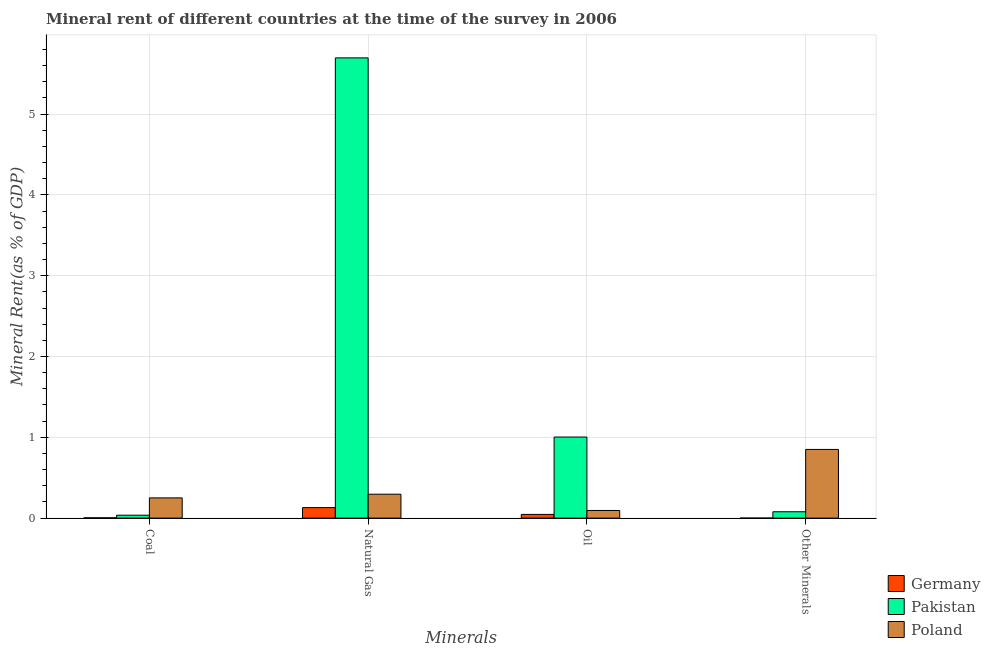How many different coloured bars are there?
Make the answer very short. 3. Are the number of bars per tick equal to the number of legend labels?
Provide a succinct answer. Yes. What is the label of the 4th group of bars from the left?
Your response must be concise. Other Minerals. What is the natural gas rent in Germany?
Your answer should be very brief. 0.13. Across all countries, what is the maximum  rent of other minerals?
Provide a short and direct response. 0.85. Across all countries, what is the minimum natural gas rent?
Give a very brief answer. 0.13. What is the total natural gas rent in the graph?
Your response must be concise. 6.12. What is the difference between the coal rent in Germany and that in Poland?
Your response must be concise. -0.25. What is the difference between the  rent of other minerals in Pakistan and the oil rent in Germany?
Your response must be concise. 0.03. What is the average coal rent per country?
Offer a terse response. 0.1. What is the difference between the  rent of other minerals and coal rent in Pakistan?
Give a very brief answer. 0.04. What is the ratio of the coal rent in Pakistan to that in Germany?
Give a very brief answer. 9.42. Is the oil rent in Germany less than that in Pakistan?
Make the answer very short. Yes. Is the difference between the oil rent in Poland and Pakistan greater than the difference between the coal rent in Poland and Pakistan?
Provide a short and direct response. No. What is the difference between the highest and the second highest coal rent?
Offer a terse response. 0.21. What is the difference between the highest and the lowest  rent of other minerals?
Your response must be concise. 0.85. How many bars are there?
Offer a terse response. 12. How many countries are there in the graph?
Your response must be concise. 3. Does the graph contain any zero values?
Your response must be concise. No. Where does the legend appear in the graph?
Give a very brief answer. Bottom right. How are the legend labels stacked?
Your response must be concise. Vertical. What is the title of the graph?
Give a very brief answer. Mineral rent of different countries at the time of the survey in 2006. Does "Guinea-Bissau" appear as one of the legend labels in the graph?
Offer a terse response. No. What is the label or title of the X-axis?
Provide a succinct answer. Minerals. What is the label or title of the Y-axis?
Offer a very short reply. Mineral Rent(as % of GDP). What is the Mineral Rent(as % of GDP) in Germany in Coal?
Make the answer very short. 0. What is the Mineral Rent(as % of GDP) of Pakistan in Coal?
Offer a very short reply. 0.04. What is the Mineral Rent(as % of GDP) in Poland in Coal?
Make the answer very short. 0.25. What is the Mineral Rent(as % of GDP) of Germany in Natural Gas?
Ensure brevity in your answer.  0.13. What is the Mineral Rent(as % of GDP) in Pakistan in Natural Gas?
Give a very brief answer. 5.7. What is the Mineral Rent(as % of GDP) of Poland in Natural Gas?
Your answer should be very brief. 0.3. What is the Mineral Rent(as % of GDP) of Germany in Oil?
Your answer should be compact. 0.05. What is the Mineral Rent(as % of GDP) in Pakistan in Oil?
Give a very brief answer. 1. What is the Mineral Rent(as % of GDP) in Poland in Oil?
Your answer should be very brief. 0.09. What is the Mineral Rent(as % of GDP) in Germany in Other Minerals?
Give a very brief answer. 0. What is the Mineral Rent(as % of GDP) of Pakistan in Other Minerals?
Your answer should be compact. 0.08. What is the Mineral Rent(as % of GDP) of Poland in Other Minerals?
Offer a very short reply. 0.85. Across all Minerals, what is the maximum Mineral Rent(as % of GDP) in Germany?
Offer a very short reply. 0.13. Across all Minerals, what is the maximum Mineral Rent(as % of GDP) in Pakistan?
Your answer should be very brief. 5.7. Across all Minerals, what is the maximum Mineral Rent(as % of GDP) of Poland?
Your response must be concise. 0.85. Across all Minerals, what is the minimum Mineral Rent(as % of GDP) in Germany?
Give a very brief answer. 0. Across all Minerals, what is the minimum Mineral Rent(as % of GDP) in Pakistan?
Keep it short and to the point. 0.04. Across all Minerals, what is the minimum Mineral Rent(as % of GDP) in Poland?
Your response must be concise. 0.09. What is the total Mineral Rent(as % of GDP) in Germany in the graph?
Provide a short and direct response. 0.18. What is the total Mineral Rent(as % of GDP) in Pakistan in the graph?
Offer a very short reply. 6.81. What is the total Mineral Rent(as % of GDP) in Poland in the graph?
Offer a very short reply. 1.49. What is the difference between the Mineral Rent(as % of GDP) of Germany in Coal and that in Natural Gas?
Give a very brief answer. -0.13. What is the difference between the Mineral Rent(as % of GDP) in Pakistan in Coal and that in Natural Gas?
Offer a terse response. -5.66. What is the difference between the Mineral Rent(as % of GDP) of Poland in Coal and that in Natural Gas?
Your answer should be very brief. -0.05. What is the difference between the Mineral Rent(as % of GDP) in Germany in Coal and that in Oil?
Provide a short and direct response. -0.04. What is the difference between the Mineral Rent(as % of GDP) of Pakistan in Coal and that in Oil?
Provide a short and direct response. -0.97. What is the difference between the Mineral Rent(as % of GDP) of Poland in Coal and that in Oil?
Your answer should be very brief. 0.16. What is the difference between the Mineral Rent(as % of GDP) of Germany in Coal and that in Other Minerals?
Provide a short and direct response. 0. What is the difference between the Mineral Rent(as % of GDP) of Pakistan in Coal and that in Other Minerals?
Keep it short and to the point. -0.04. What is the difference between the Mineral Rent(as % of GDP) of Poland in Coal and that in Other Minerals?
Provide a short and direct response. -0.6. What is the difference between the Mineral Rent(as % of GDP) in Germany in Natural Gas and that in Oil?
Offer a terse response. 0.08. What is the difference between the Mineral Rent(as % of GDP) of Pakistan in Natural Gas and that in Oil?
Give a very brief answer. 4.69. What is the difference between the Mineral Rent(as % of GDP) of Poland in Natural Gas and that in Oil?
Give a very brief answer. 0.2. What is the difference between the Mineral Rent(as % of GDP) in Germany in Natural Gas and that in Other Minerals?
Provide a succinct answer. 0.13. What is the difference between the Mineral Rent(as % of GDP) of Pakistan in Natural Gas and that in Other Minerals?
Your answer should be very brief. 5.62. What is the difference between the Mineral Rent(as % of GDP) of Poland in Natural Gas and that in Other Minerals?
Your response must be concise. -0.55. What is the difference between the Mineral Rent(as % of GDP) of Germany in Oil and that in Other Minerals?
Your answer should be compact. 0.05. What is the difference between the Mineral Rent(as % of GDP) of Pakistan in Oil and that in Other Minerals?
Your answer should be very brief. 0.92. What is the difference between the Mineral Rent(as % of GDP) in Poland in Oil and that in Other Minerals?
Your response must be concise. -0.76. What is the difference between the Mineral Rent(as % of GDP) of Germany in Coal and the Mineral Rent(as % of GDP) of Pakistan in Natural Gas?
Ensure brevity in your answer.  -5.69. What is the difference between the Mineral Rent(as % of GDP) in Germany in Coal and the Mineral Rent(as % of GDP) in Poland in Natural Gas?
Your answer should be very brief. -0.29. What is the difference between the Mineral Rent(as % of GDP) in Pakistan in Coal and the Mineral Rent(as % of GDP) in Poland in Natural Gas?
Provide a short and direct response. -0.26. What is the difference between the Mineral Rent(as % of GDP) in Germany in Coal and the Mineral Rent(as % of GDP) in Pakistan in Oil?
Offer a terse response. -1. What is the difference between the Mineral Rent(as % of GDP) in Germany in Coal and the Mineral Rent(as % of GDP) in Poland in Oil?
Your answer should be very brief. -0.09. What is the difference between the Mineral Rent(as % of GDP) in Pakistan in Coal and the Mineral Rent(as % of GDP) in Poland in Oil?
Offer a terse response. -0.06. What is the difference between the Mineral Rent(as % of GDP) of Germany in Coal and the Mineral Rent(as % of GDP) of Pakistan in Other Minerals?
Make the answer very short. -0.07. What is the difference between the Mineral Rent(as % of GDP) in Germany in Coal and the Mineral Rent(as % of GDP) in Poland in Other Minerals?
Offer a very short reply. -0.85. What is the difference between the Mineral Rent(as % of GDP) of Pakistan in Coal and the Mineral Rent(as % of GDP) of Poland in Other Minerals?
Make the answer very short. -0.81. What is the difference between the Mineral Rent(as % of GDP) in Germany in Natural Gas and the Mineral Rent(as % of GDP) in Pakistan in Oil?
Your answer should be very brief. -0.87. What is the difference between the Mineral Rent(as % of GDP) of Germany in Natural Gas and the Mineral Rent(as % of GDP) of Poland in Oil?
Keep it short and to the point. 0.04. What is the difference between the Mineral Rent(as % of GDP) in Pakistan in Natural Gas and the Mineral Rent(as % of GDP) in Poland in Oil?
Your answer should be compact. 5.6. What is the difference between the Mineral Rent(as % of GDP) in Germany in Natural Gas and the Mineral Rent(as % of GDP) in Pakistan in Other Minerals?
Keep it short and to the point. 0.05. What is the difference between the Mineral Rent(as % of GDP) in Germany in Natural Gas and the Mineral Rent(as % of GDP) in Poland in Other Minerals?
Provide a short and direct response. -0.72. What is the difference between the Mineral Rent(as % of GDP) of Pakistan in Natural Gas and the Mineral Rent(as % of GDP) of Poland in Other Minerals?
Keep it short and to the point. 4.85. What is the difference between the Mineral Rent(as % of GDP) in Germany in Oil and the Mineral Rent(as % of GDP) in Pakistan in Other Minerals?
Provide a short and direct response. -0.03. What is the difference between the Mineral Rent(as % of GDP) in Germany in Oil and the Mineral Rent(as % of GDP) in Poland in Other Minerals?
Your answer should be compact. -0.8. What is the difference between the Mineral Rent(as % of GDP) of Pakistan in Oil and the Mineral Rent(as % of GDP) of Poland in Other Minerals?
Provide a succinct answer. 0.15. What is the average Mineral Rent(as % of GDP) of Germany per Minerals?
Keep it short and to the point. 0.05. What is the average Mineral Rent(as % of GDP) of Pakistan per Minerals?
Your answer should be compact. 1.7. What is the average Mineral Rent(as % of GDP) of Poland per Minerals?
Ensure brevity in your answer.  0.37. What is the difference between the Mineral Rent(as % of GDP) in Germany and Mineral Rent(as % of GDP) in Pakistan in Coal?
Keep it short and to the point. -0.03. What is the difference between the Mineral Rent(as % of GDP) of Germany and Mineral Rent(as % of GDP) of Poland in Coal?
Provide a succinct answer. -0.25. What is the difference between the Mineral Rent(as % of GDP) of Pakistan and Mineral Rent(as % of GDP) of Poland in Coal?
Offer a terse response. -0.21. What is the difference between the Mineral Rent(as % of GDP) of Germany and Mineral Rent(as % of GDP) of Pakistan in Natural Gas?
Your response must be concise. -5.57. What is the difference between the Mineral Rent(as % of GDP) in Germany and Mineral Rent(as % of GDP) in Poland in Natural Gas?
Keep it short and to the point. -0.17. What is the difference between the Mineral Rent(as % of GDP) in Pakistan and Mineral Rent(as % of GDP) in Poland in Natural Gas?
Your response must be concise. 5.4. What is the difference between the Mineral Rent(as % of GDP) of Germany and Mineral Rent(as % of GDP) of Pakistan in Oil?
Provide a succinct answer. -0.96. What is the difference between the Mineral Rent(as % of GDP) of Germany and Mineral Rent(as % of GDP) of Poland in Oil?
Keep it short and to the point. -0.05. What is the difference between the Mineral Rent(as % of GDP) of Pakistan and Mineral Rent(as % of GDP) of Poland in Oil?
Give a very brief answer. 0.91. What is the difference between the Mineral Rent(as % of GDP) of Germany and Mineral Rent(as % of GDP) of Pakistan in Other Minerals?
Your answer should be very brief. -0.08. What is the difference between the Mineral Rent(as % of GDP) of Germany and Mineral Rent(as % of GDP) of Poland in Other Minerals?
Offer a terse response. -0.85. What is the difference between the Mineral Rent(as % of GDP) in Pakistan and Mineral Rent(as % of GDP) in Poland in Other Minerals?
Give a very brief answer. -0.77. What is the ratio of the Mineral Rent(as % of GDP) of Germany in Coal to that in Natural Gas?
Offer a terse response. 0.03. What is the ratio of the Mineral Rent(as % of GDP) in Pakistan in Coal to that in Natural Gas?
Give a very brief answer. 0.01. What is the ratio of the Mineral Rent(as % of GDP) of Poland in Coal to that in Natural Gas?
Offer a very short reply. 0.85. What is the ratio of the Mineral Rent(as % of GDP) in Germany in Coal to that in Oil?
Your answer should be very brief. 0.08. What is the ratio of the Mineral Rent(as % of GDP) of Pakistan in Coal to that in Oil?
Offer a very short reply. 0.04. What is the ratio of the Mineral Rent(as % of GDP) of Poland in Coal to that in Oil?
Offer a very short reply. 2.65. What is the ratio of the Mineral Rent(as % of GDP) in Germany in Coal to that in Other Minerals?
Ensure brevity in your answer.  9.22. What is the ratio of the Mineral Rent(as % of GDP) in Pakistan in Coal to that in Other Minerals?
Give a very brief answer. 0.46. What is the ratio of the Mineral Rent(as % of GDP) in Poland in Coal to that in Other Minerals?
Provide a succinct answer. 0.29. What is the ratio of the Mineral Rent(as % of GDP) in Germany in Natural Gas to that in Oil?
Make the answer very short. 2.83. What is the ratio of the Mineral Rent(as % of GDP) in Pakistan in Natural Gas to that in Oil?
Your answer should be very brief. 5.68. What is the ratio of the Mineral Rent(as % of GDP) of Poland in Natural Gas to that in Oil?
Your answer should be very brief. 3.13. What is the ratio of the Mineral Rent(as % of GDP) of Germany in Natural Gas to that in Other Minerals?
Give a very brief answer. 313.19. What is the ratio of the Mineral Rent(as % of GDP) in Pakistan in Natural Gas to that in Other Minerals?
Ensure brevity in your answer.  72.35. What is the ratio of the Mineral Rent(as % of GDP) of Poland in Natural Gas to that in Other Minerals?
Offer a very short reply. 0.35. What is the ratio of the Mineral Rent(as % of GDP) in Germany in Oil to that in Other Minerals?
Give a very brief answer. 110.61. What is the ratio of the Mineral Rent(as % of GDP) in Pakistan in Oil to that in Other Minerals?
Make the answer very short. 12.75. What is the ratio of the Mineral Rent(as % of GDP) of Poland in Oil to that in Other Minerals?
Offer a very short reply. 0.11. What is the difference between the highest and the second highest Mineral Rent(as % of GDP) of Germany?
Provide a short and direct response. 0.08. What is the difference between the highest and the second highest Mineral Rent(as % of GDP) of Pakistan?
Ensure brevity in your answer.  4.69. What is the difference between the highest and the second highest Mineral Rent(as % of GDP) of Poland?
Your answer should be very brief. 0.55. What is the difference between the highest and the lowest Mineral Rent(as % of GDP) in Germany?
Provide a succinct answer. 0.13. What is the difference between the highest and the lowest Mineral Rent(as % of GDP) of Pakistan?
Give a very brief answer. 5.66. What is the difference between the highest and the lowest Mineral Rent(as % of GDP) of Poland?
Provide a succinct answer. 0.76. 